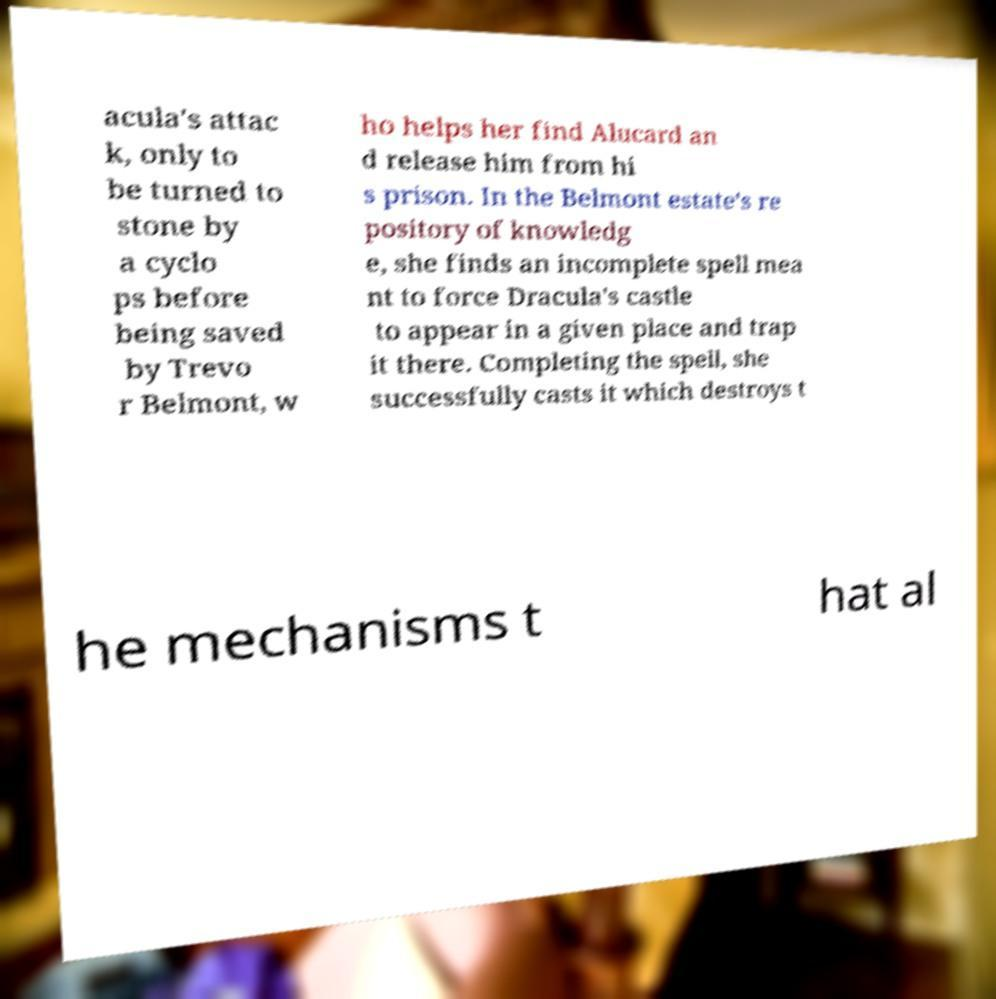Could you assist in decoding the text presented in this image and type it out clearly? acula's attac k, only to be turned to stone by a cyclo ps before being saved by Trevo r Belmont, w ho helps her find Alucard an d release him from hi s prison. In the Belmont estate's re pository of knowledg e, she finds an incomplete spell mea nt to force Dracula's castle to appear in a given place and trap it there. Completing the spell, she successfully casts it which destroys t he mechanisms t hat al 